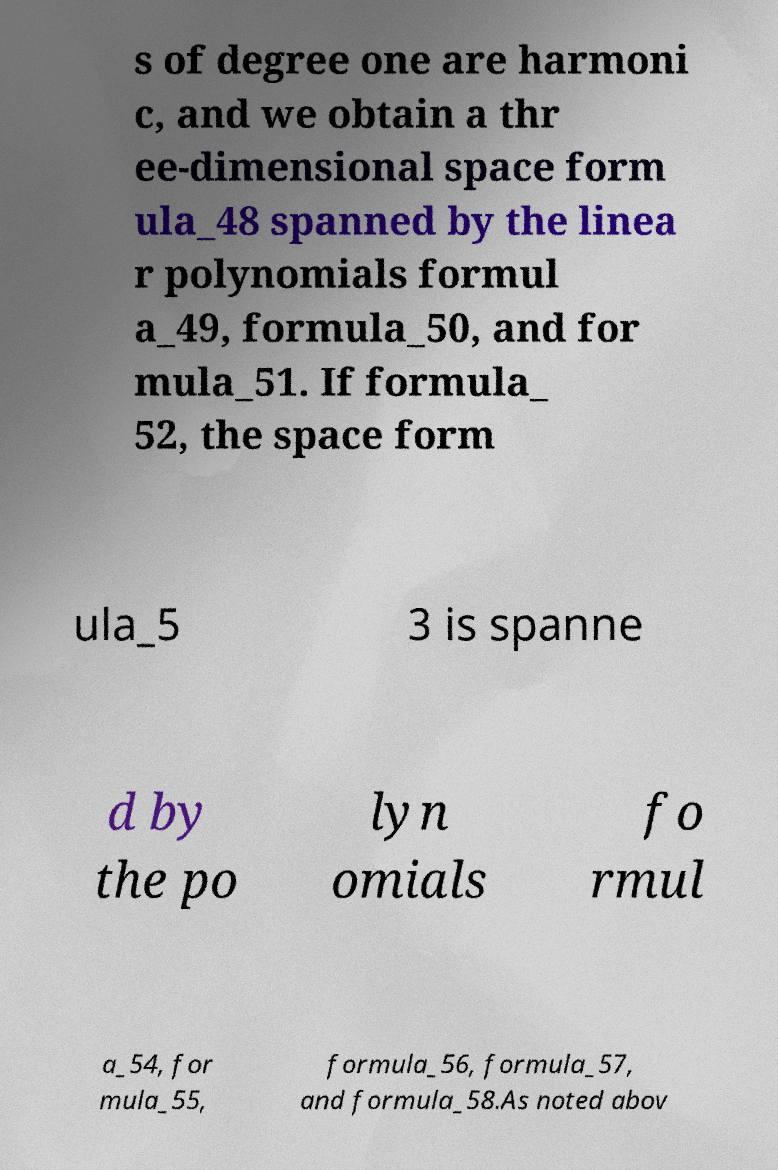There's text embedded in this image that I need extracted. Can you transcribe it verbatim? s of degree one are harmoni c, and we obtain a thr ee-dimensional space form ula_48 spanned by the linea r polynomials formul a_49, formula_50, and for mula_51. If formula_ 52, the space form ula_5 3 is spanne d by the po lyn omials fo rmul a_54, for mula_55, formula_56, formula_57, and formula_58.As noted abov 